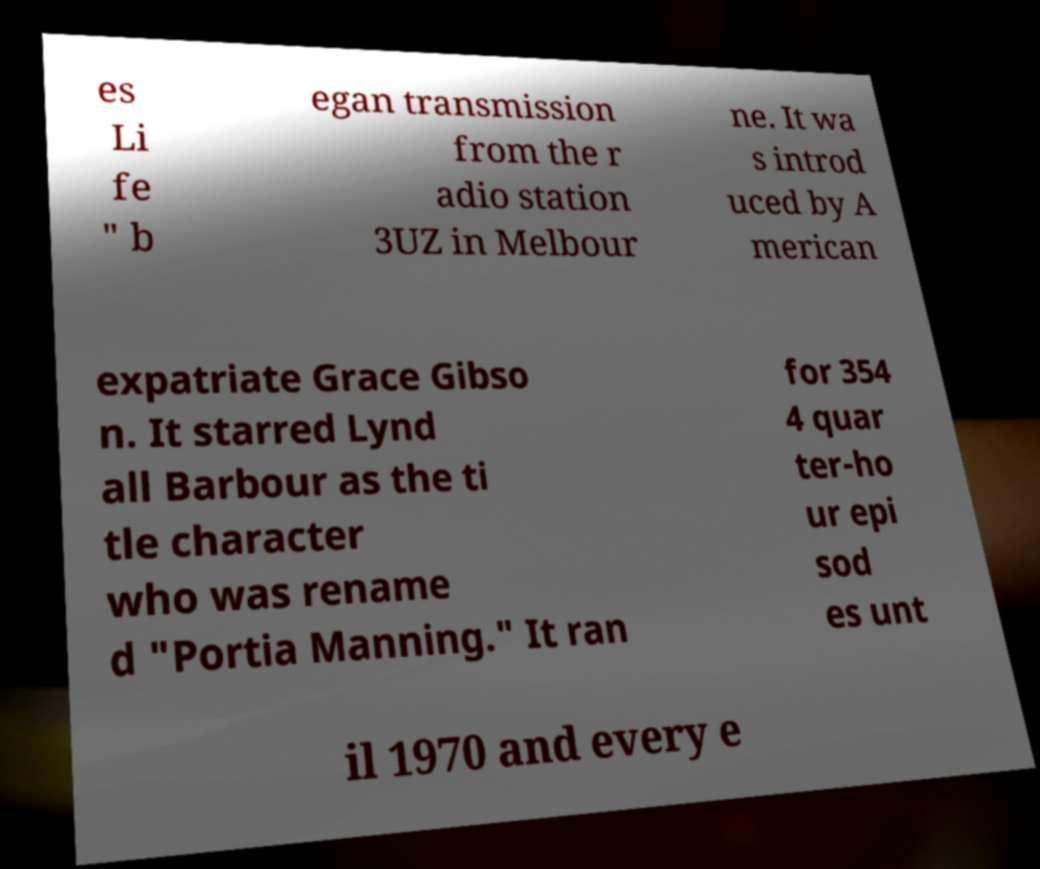Please read and relay the text visible in this image. What does it say? es Li fe " b egan transmission from the r adio station 3UZ in Melbour ne. It wa s introd uced by A merican expatriate Grace Gibso n. It starred Lynd all Barbour as the ti tle character who was rename d "Portia Manning." It ran for 354 4 quar ter-ho ur epi sod es unt il 1970 and every e 